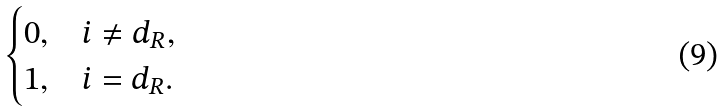Convert formula to latex. <formula><loc_0><loc_0><loc_500><loc_500>\begin{cases} 0 , & i \neq d _ { R } , \\ 1 , & i = d _ { R } . \end{cases}</formula> 